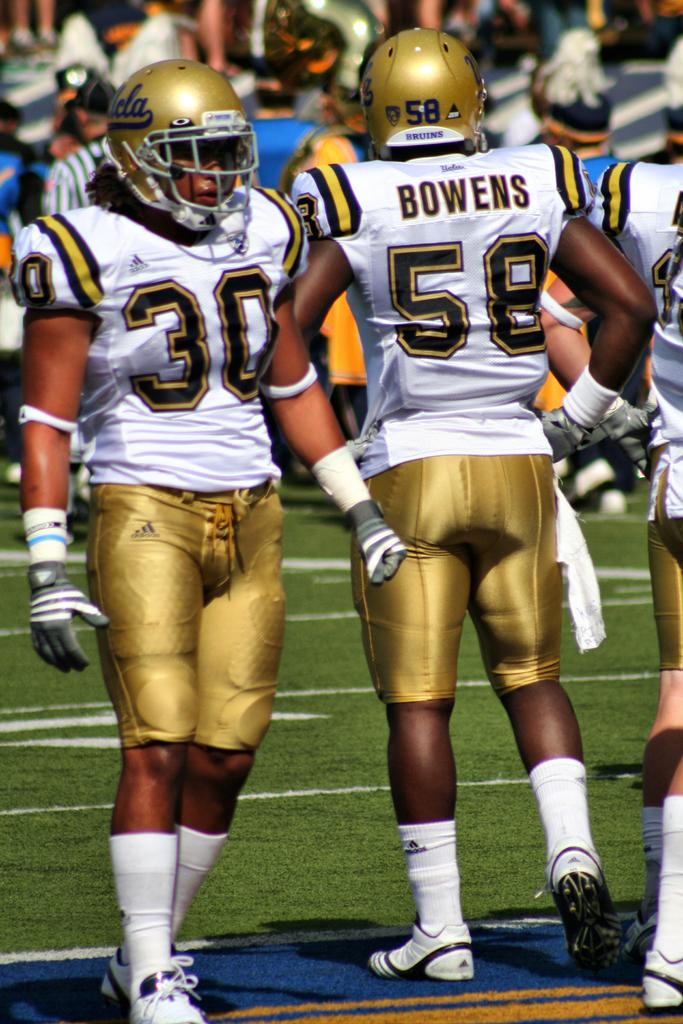What is at the bottom of the image? There is ground at the bottom of the image. Who or what is in the foreground of the image? There are people in the foreground of the image. Who or what is in the background of the image? There are people in the background of the image. What type of self can be seen in the image? There is no self present in the image; it features people in the foreground and background. What is the base of the image made of? The base of the image, which refers to the ground at the bottom, is not made of anything, as it is a part of the image itself. 